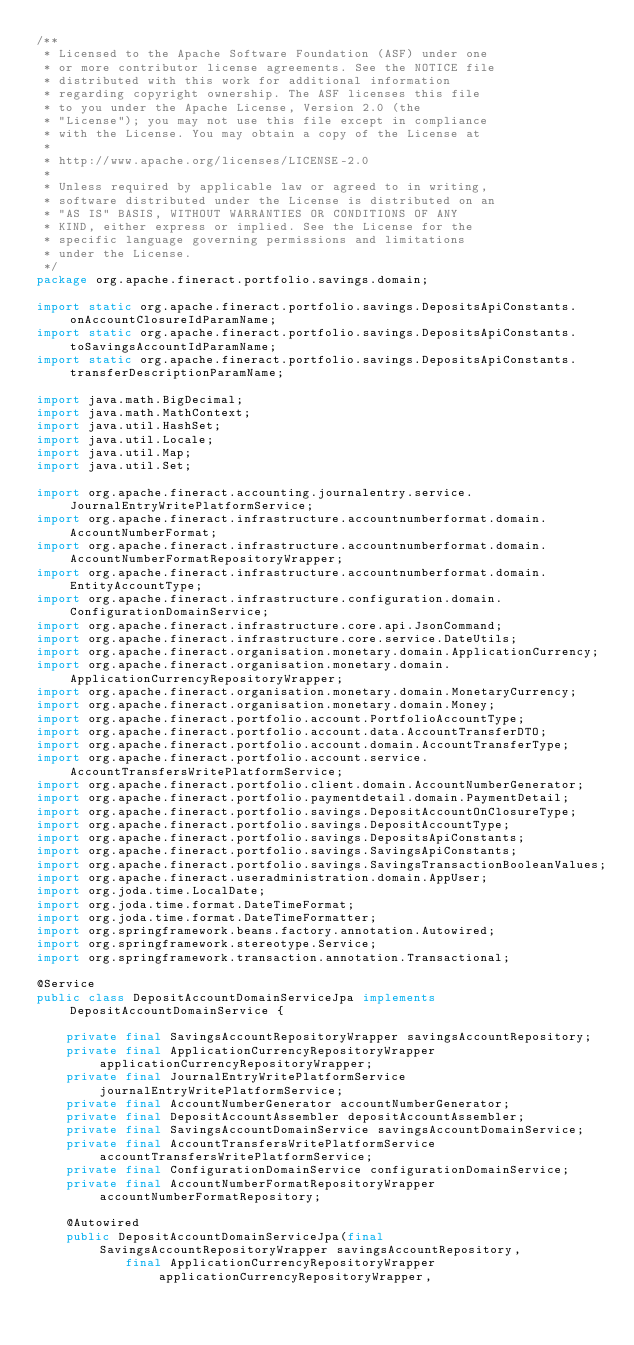<code> <loc_0><loc_0><loc_500><loc_500><_Java_>/**
 * Licensed to the Apache Software Foundation (ASF) under one
 * or more contributor license agreements. See the NOTICE file
 * distributed with this work for additional information
 * regarding copyright ownership. The ASF licenses this file
 * to you under the Apache License, Version 2.0 (the
 * "License"); you may not use this file except in compliance
 * with the License. You may obtain a copy of the License at
 *
 * http://www.apache.org/licenses/LICENSE-2.0
 *
 * Unless required by applicable law or agreed to in writing,
 * software distributed under the License is distributed on an
 * "AS IS" BASIS, WITHOUT WARRANTIES OR CONDITIONS OF ANY
 * KIND, either express or implied. See the License for the
 * specific language governing permissions and limitations
 * under the License.
 */
package org.apache.fineract.portfolio.savings.domain;

import static org.apache.fineract.portfolio.savings.DepositsApiConstants.onAccountClosureIdParamName;
import static org.apache.fineract.portfolio.savings.DepositsApiConstants.toSavingsAccountIdParamName;
import static org.apache.fineract.portfolio.savings.DepositsApiConstants.transferDescriptionParamName;

import java.math.BigDecimal;
import java.math.MathContext;
import java.util.HashSet;
import java.util.Locale;
import java.util.Map;
import java.util.Set;

import org.apache.fineract.accounting.journalentry.service.JournalEntryWritePlatformService;
import org.apache.fineract.infrastructure.accountnumberformat.domain.AccountNumberFormat;
import org.apache.fineract.infrastructure.accountnumberformat.domain.AccountNumberFormatRepositoryWrapper;
import org.apache.fineract.infrastructure.accountnumberformat.domain.EntityAccountType;
import org.apache.fineract.infrastructure.configuration.domain.ConfigurationDomainService;
import org.apache.fineract.infrastructure.core.api.JsonCommand;
import org.apache.fineract.infrastructure.core.service.DateUtils;
import org.apache.fineract.organisation.monetary.domain.ApplicationCurrency;
import org.apache.fineract.organisation.monetary.domain.ApplicationCurrencyRepositoryWrapper;
import org.apache.fineract.organisation.monetary.domain.MonetaryCurrency;
import org.apache.fineract.organisation.monetary.domain.Money;
import org.apache.fineract.portfolio.account.PortfolioAccountType;
import org.apache.fineract.portfolio.account.data.AccountTransferDTO;
import org.apache.fineract.portfolio.account.domain.AccountTransferType;
import org.apache.fineract.portfolio.account.service.AccountTransfersWritePlatformService;
import org.apache.fineract.portfolio.client.domain.AccountNumberGenerator;
import org.apache.fineract.portfolio.paymentdetail.domain.PaymentDetail;
import org.apache.fineract.portfolio.savings.DepositAccountOnClosureType;
import org.apache.fineract.portfolio.savings.DepositAccountType;
import org.apache.fineract.portfolio.savings.DepositsApiConstants;
import org.apache.fineract.portfolio.savings.SavingsApiConstants;
import org.apache.fineract.portfolio.savings.SavingsTransactionBooleanValues;
import org.apache.fineract.useradministration.domain.AppUser;
import org.joda.time.LocalDate;
import org.joda.time.format.DateTimeFormat;
import org.joda.time.format.DateTimeFormatter;
import org.springframework.beans.factory.annotation.Autowired;
import org.springframework.stereotype.Service;
import org.springframework.transaction.annotation.Transactional;

@Service
public class DepositAccountDomainServiceJpa implements DepositAccountDomainService {

    private final SavingsAccountRepositoryWrapper savingsAccountRepository;
    private final ApplicationCurrencyRepositoryWrapper applicationCurrencyRepositoryWrapper;
    private final JournalEntryWritePlatformService journalEntryWritePlatformService;
    private final AccountNumberGenerator accountNumberGenerator;
    private final DepositAccountAssembler depositAccountAssembler;
    private final SavingsAccountDomainService savingsAccountDomainService;
    private final AccountTransfersWritePlatformService accountTransfersWritePlatformService;
    private final ConfigurationDomainService configurationDomainService;
    private final AccountNumberFormatRepositoryWrapper accountNumberFormatRepository;

    @Autowired
    public DepositAccountDomainServiceJpa(final SavingsAccountRepositoryWrapper savingsAccountRepository,
            final ApplicationCurrencyRepositoryWrapper applicationCurrencyRepositoryWrapper,</code> 